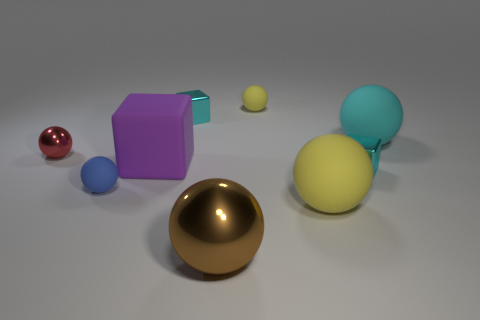Are there any other things that are the same material as the brown sphere?
Your answer should be compact. Yes. There is a block on the right side of the large metal thing; what is it made of?
Your answer should be compact. Metal. What is the color of the matte ball that is left of the tiny rubber sphere right of the small matte sphere left of the purple block?
Ensure brevity in your answer.  Blue. What color is the metal object that is the same size as the purple block?
Your response must be concise. Brown. How many metal things are either large blocks or small cyan objects?
Provide a succinct answer. 2. What is the color of the large ball that is made of the same material as the small red ball?
Your answer should be very brief. Brown. The small ball on the left side of the small ball in front of the big rubber block is made of what material?
Provide a succinct answer. Metal. How many things are either tiny metallic objects that are in front of the tiny red object or small shiny objects that are in front of the small red object?
Make the answer very short. 1. What size is the yellow sphere in front of the small metallic block that is to the right of the tiny rubber thing right of the big brown object?
Offer a terse response. Large. Are there the same number of big yellow objects on the left side of the big purple matte object and tiny blue rubber cylinders?
Offer a very short reply. Yes. 